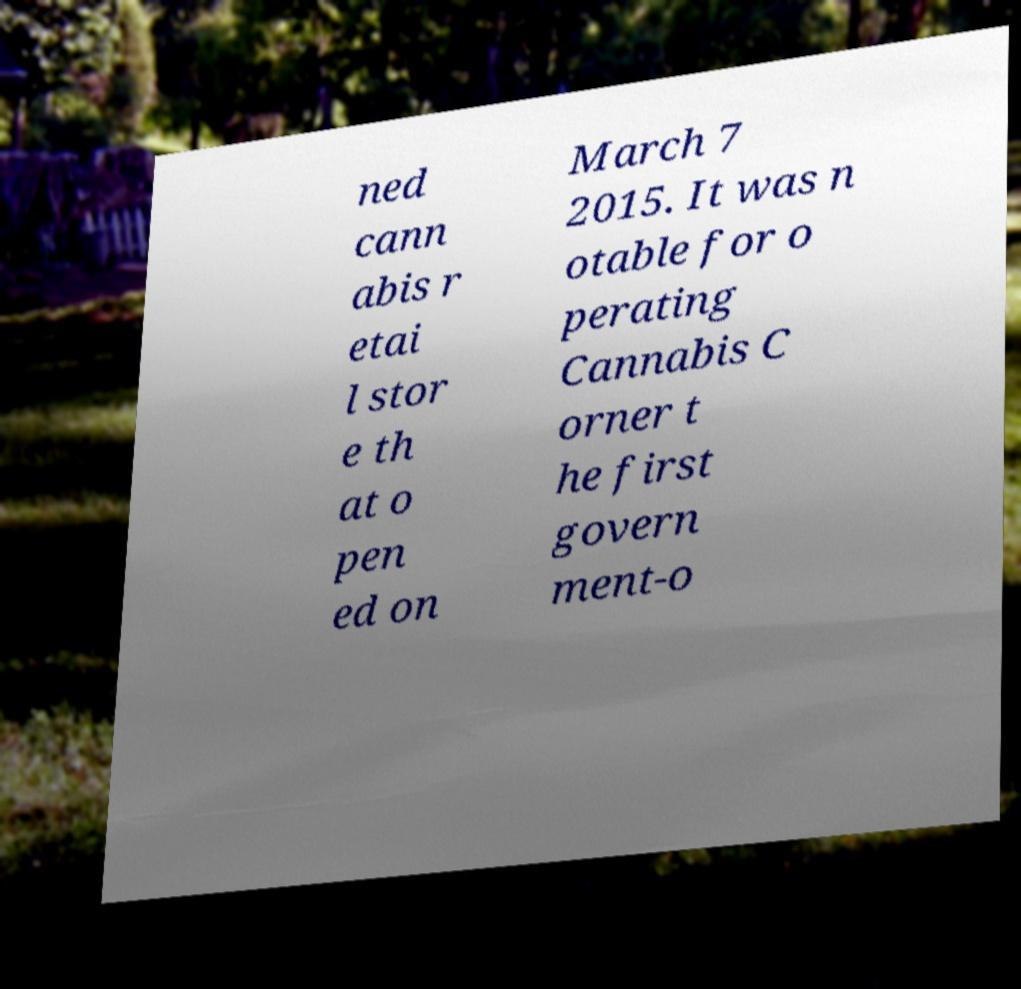Please identify and transcribe the text found in this image. ned cann abis r etai l stor e th at o pen ed on March 7 2015. It was n otable for o perating Cannabis C orner t he first govern ment-o 